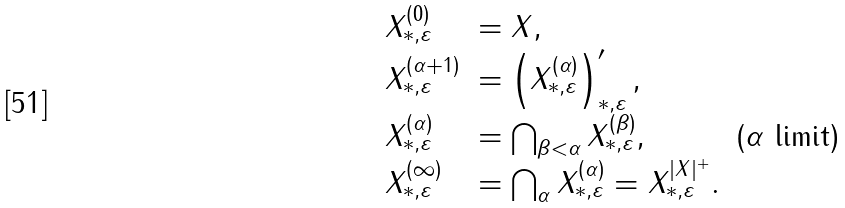<formula> <loc_0><loc_0><loc_500><loc_500>\begin{array} { l l r } X ^ { ( 0 ) } _ { * , \varepsilon } & = X , \\ X ^ { ( \alpha + 1 ) } _ { * , \varepsilon } & = \left ( X ^ { ( \alpha ) } _ { * , \varepsilon } \right ) ^ { \prime } _ { * , \varepsilon } , \\ X ^ { ( \alpha ) } _ { * , \varepsilon } & = \bigcap _ { \beta < \alpha } X ^ { ( \beta ) } _ { * , \varepsilon } , & ( \alpha \text { limit} ) \\ X ^ { ( \infty ) } _ { * , \varepsilon } & = \bigcap _ { \alpha } X ^ { ( \alpha ) } _ { * , \varepsilon } = X ^ { | X | ^ { + } } _ { * , \varepsilon } . \end{array}</formula> 